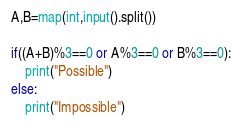Convert code to text. <code><loc_0><loc_0><loc_500><loc_500><_Python_>A,B=map(int,input().split())

if((A+B)%3==0 or A%3==0 or B%3==0):
    print("Possible")
else:
    print("Impossible")</code> 